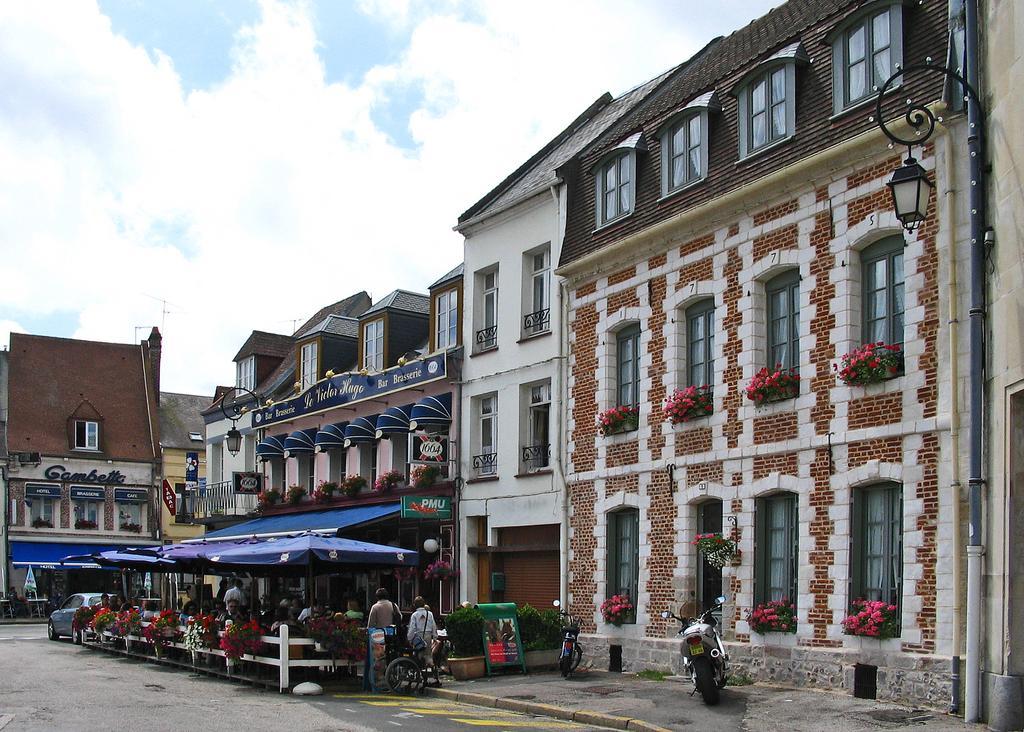Can you describe this image briefly? In this image I can see the ground, the white colored railing, few flowers which are white and red in color, few persons sitting, few vehicles, few boards, a black colored street light pole and few buildings. In the background I can see the sky. 